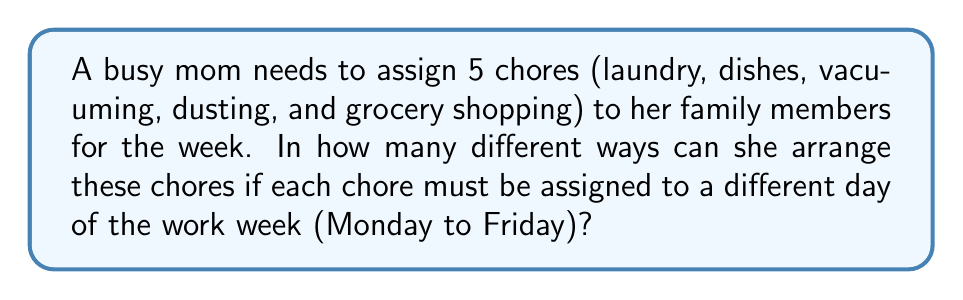Solve this math problem. Let's approach this step-by-step:

1) This problem is a straightforward permutation. We are arranging 5 distinct chores into 5 distinct days.

2) In permutation problems, the order matters. For example, assigning laundry to Monday and dishes to Tuesday is different from assigning dishes to Monday and laundry to Tuesday.

3) The formula for permutations of n distinct objects is:

   $$P(n) = n!$$

   Where $n!$ represents the factorial of n.

4) In this case, $n = 5$ (5 chores to be arranged in 5 days)

5) Therefore, the number of ways to arrange the chores is:

   $$P(5) = 5!$$

6) Let's calculate 5!:
   
   $$5! = 5 \times 4 \times 3 \times 2 \times 1 = 120$$

Thus, there are 120 different ways to arrange the 5 chores over the 5 weekdays.
Answer: $120$ 